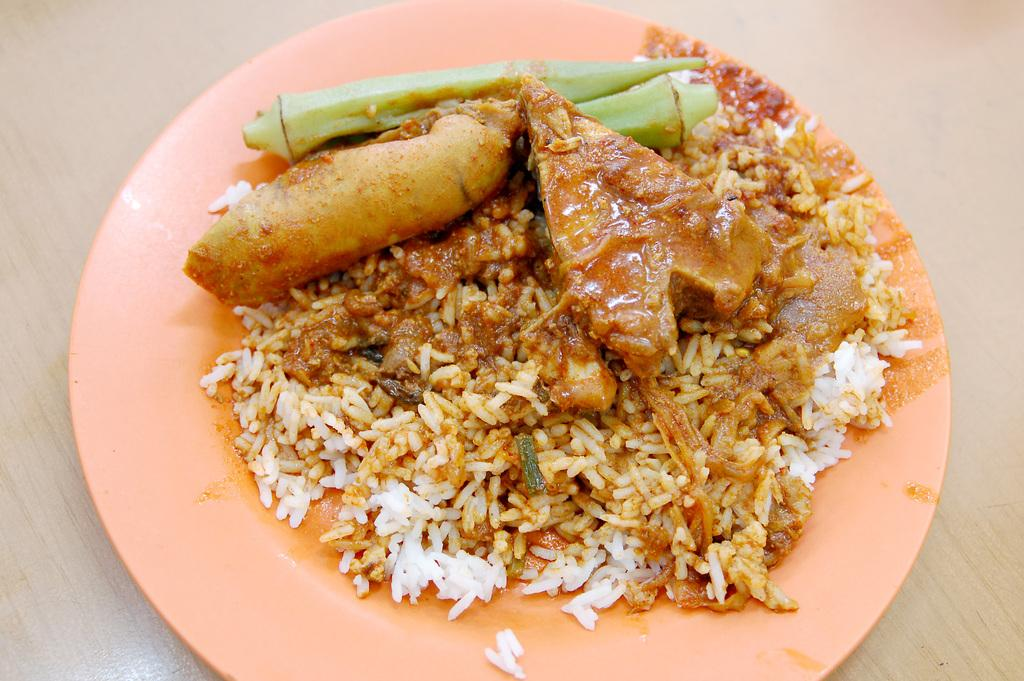What is the main subject of the image? The main subject of the image is food. Where is the food located in the image? The food is in the center of the image. How is the food presented in the image? The food is on a plate. What type of rake is being used to adjust the food on the plate in the image? There is no rake present in the image, and the food is not being adjusted. 